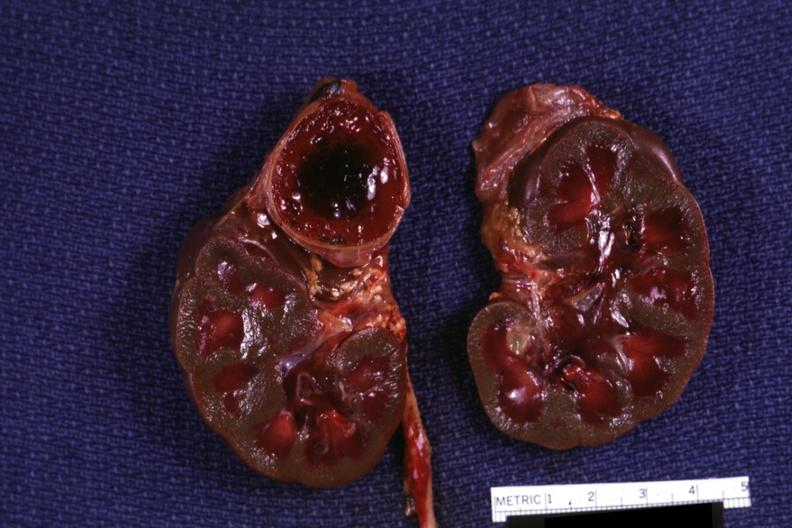s endocrine present?
Answer the question using a single word or phrase. Yes 